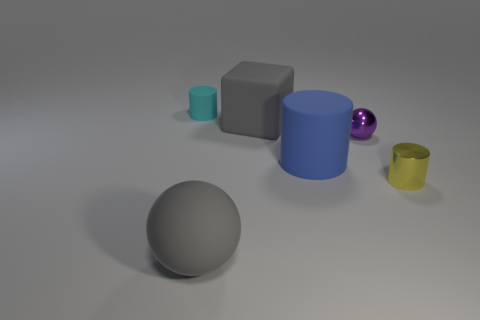Add 1 purple objects. How many objects exist? 7 Subtract all blocks. How many objects are left? 5 Add 6 large shiny things. How many large shiny things exist? 6 Subtract 0 cyan spheres. How many objects are left? 6 Subtract all tiny green metal cubes. Subtract all small metal objects. How many objects are left? 4 Add 2 small purple metallic spheres. How many small purple metallic spheres are left? 3 